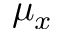Convert formula to latex. <formula><loc_0><loc_0><loc_500><loc_500>\mu _ { x }</formula> 